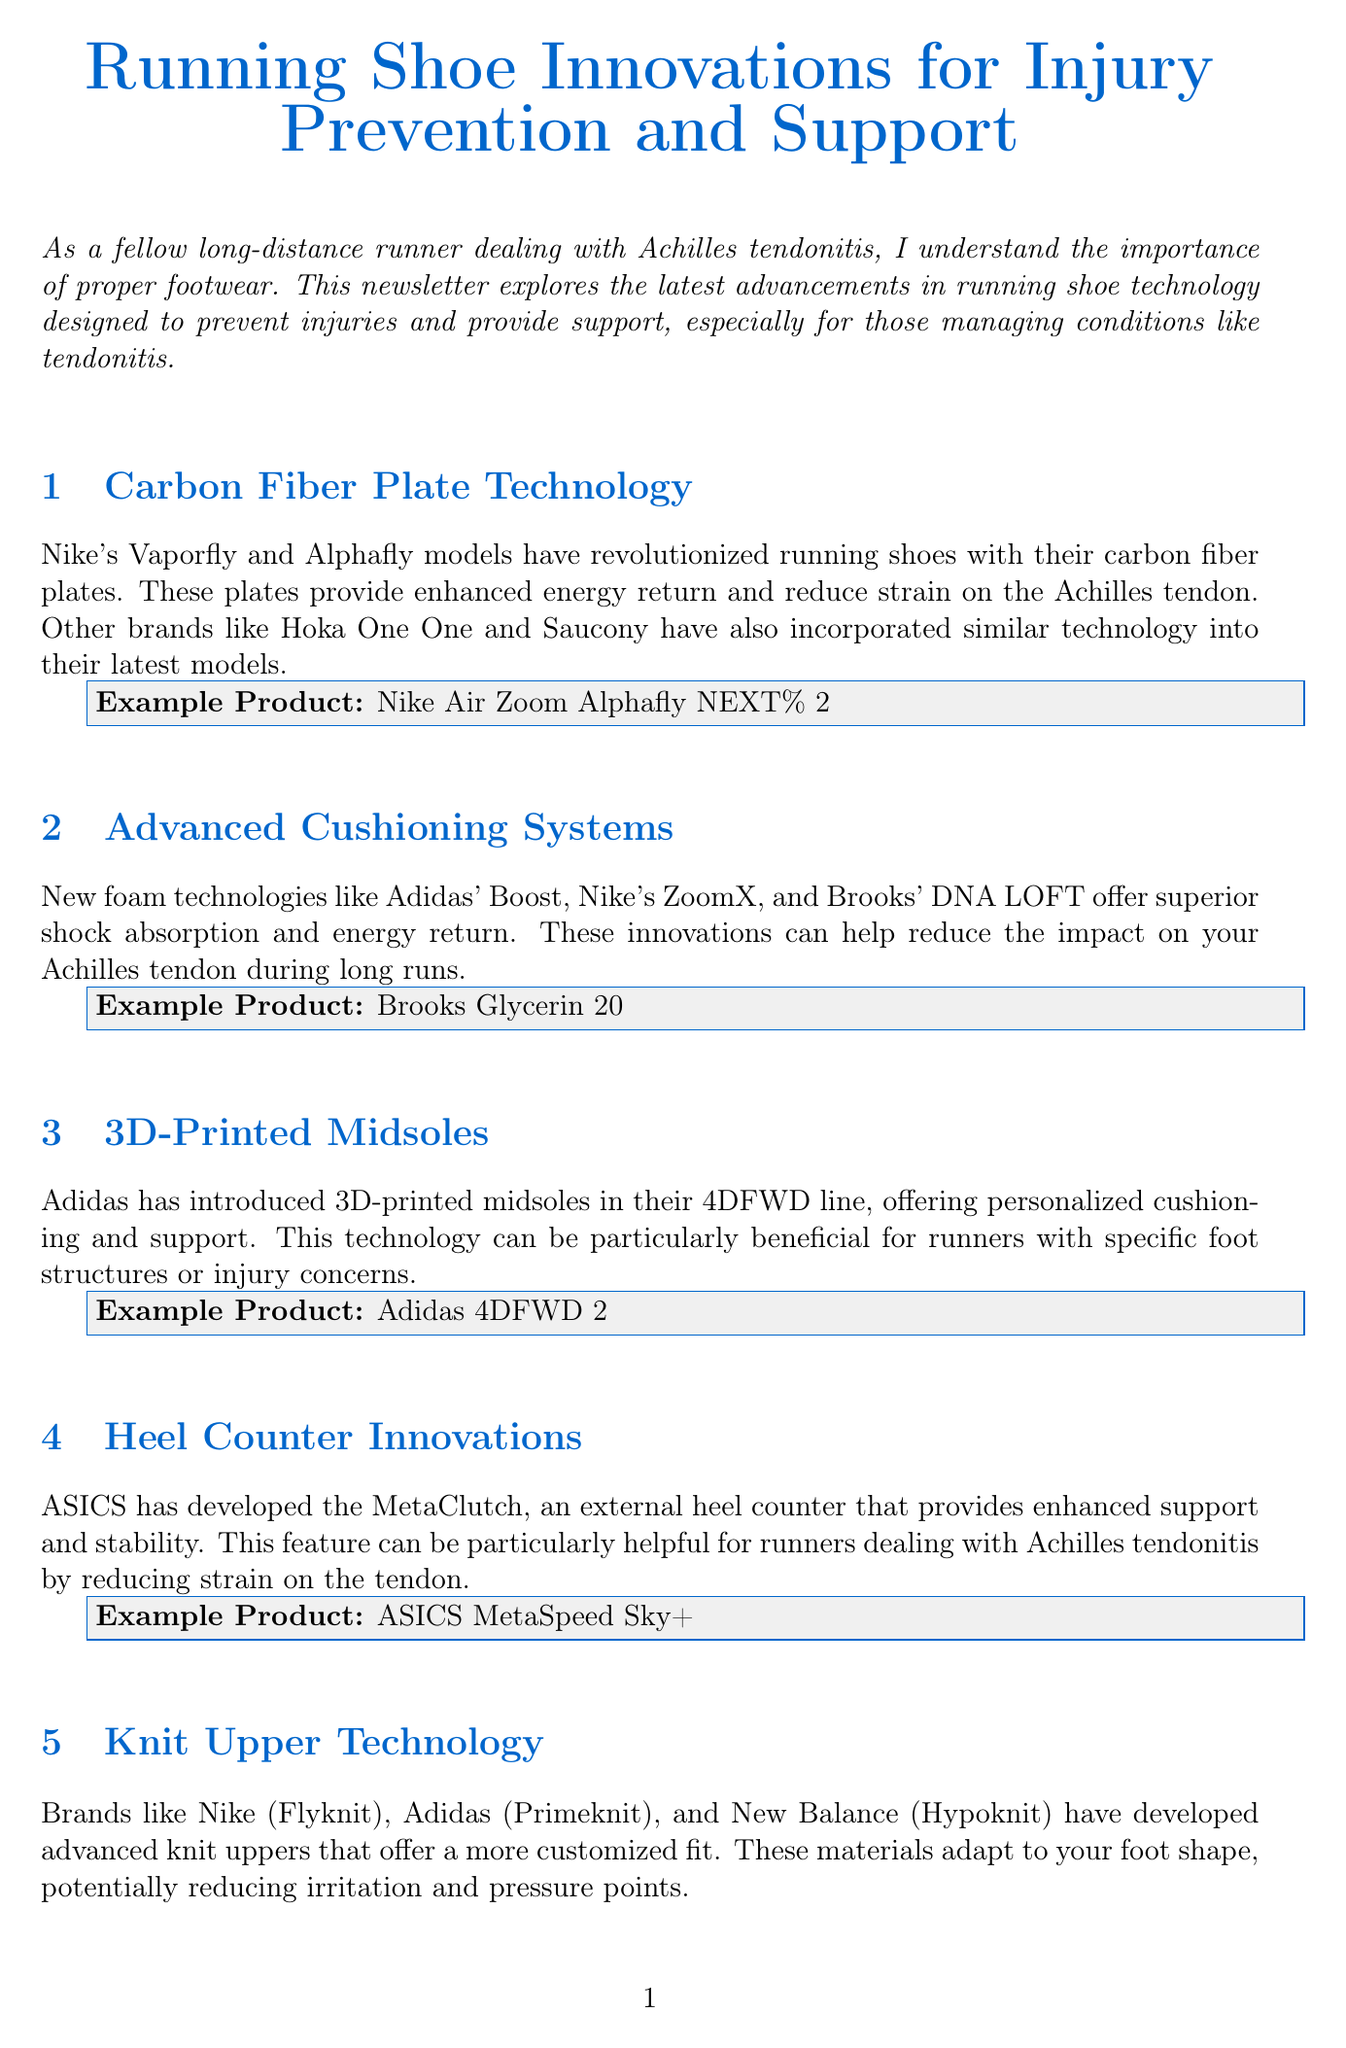what is the title of the newsletter? The title is clearly stated at the beginning of the document.
Answer: Running Shoe Innovations for Injury Prevention and Support which brand developed the external heel counter called MetaClutch? The document specifies that ASICS developed this technology.
Answer: ASICS what is an example product featuring advanced cushioning systems? The newsletter provides specific example products under each section.
Answer: Brooks Glycerin 20 which technology helps promote a smoother heel-to-toe transition? The document describes the rocker sole design as beneficial for this purpose.
Answer: Rocker Sole Design what type of technology does Adidas use in their 4DFWD line? The content in the document outlines the technology employed in this Adidas line.
Answer: 3D-Printed Midsoles how many sections are there in the newsletter? The document lists and provides content for six distinct sections.
Answer: 6 what is one of the additional resources listed for running shoe guidance? The document includes multiple resources for further reading.
Answer: Runner's World Shoe Finder which cushioning technology is associated with Nike? The newsletter mentions various brands along with their specific technologies.
Answer: ZoomX 